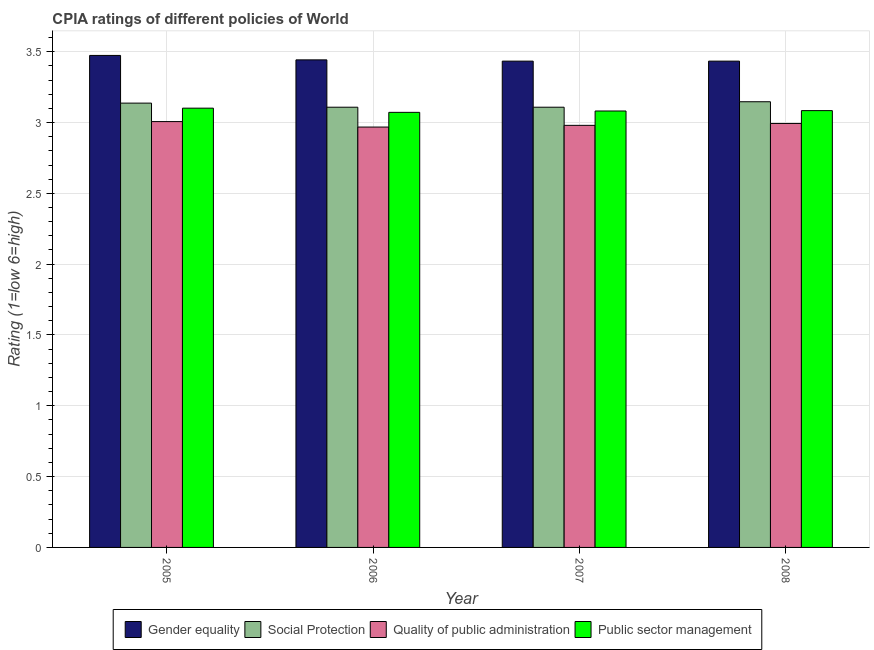How many different coloured bars are there?
Give a very brief answer. 4. How many groups of bars are there?
Make the answer very short. 4. Are the number of bars per tick equal to the number of legend labels?
Give a very brief answer. Yes. Are the number of bars on each tick of the X-axis equal?
Offer a very short reply. Yes. How many bars are there on the 3rd tick from the left?
Offer a terse response. 4. What is the label of the 3rd group of bars from the left?
Offer a very short reply. 2007. In how many cases, is the number of bars for a given year not equal to the number of legend labels?
Your answer should be compact. 0. What is the cpia rating of quality of public administration in 2007?
Keep it short and to the point. 2.98. Across all years, what is the maximum cpia rating of social protection?
Provide a short and direct response. 3.15. Across all years, what is the minimum cpia rating of gender equality?
Provide a short and direct response. 3.43. In which year was the cpia rating of quality of public administration maximum?
Make the answer very short. 2005. In which year was the cpia rating of quality of public administration minimum?
Offer a very short reply. 2006. What is the total cpia rating of quality of public administration in the graph?
Keep it short and to the point. 11.95. What is the difference between the cpia rating of quality of public administration in 2006 and that in 2007?
Ensure brevity in your answer.  -0.01. What is the difference between the cpia rating of gender equality in 2007 and the cpia rating of social protection in 2006?
Provide a succinct answer. -0.01. What is the average cpia rating of gender equality per year?
Keep it short and to the point. 3.45. In how many years, is the cpia rating of quality of public administration greater than 1.2?
Offer a terse response. 4. What is the ratio of the cpia rating of social protection in 2006 to that in 2008?
Offer a very short reply. 0.99. Is the cpia rating of quality of public administration in 2006 less than that in 2008?
Ensure brevity in your answer.  Yes. What is the difference between the highest and the second highest cpia rating of quality of public administration?
Offer a terse response. 0.01. What is the difference between the highest and the lowest cpia rating of quality of public administration?
Provide a short and direct response. 0.04. In how many years, is the cpia rating of quality of public administration greater than the average cpia rating of quality of public administration taken over all years?
Provide a short and direct response. 2. Is it the case that in every year, the sum of the cpia rating of gender equality and cpia rating of social protection is greater than the sum of cpia rating of public sector management and cpia rating of quality of public administration?
Offer a terse response. Yes. What does the 3rd bar from the left in 2005 represents?
Keep it short and to the point. Quality of public administration. What does the 3rd bar from the right in 2006 represents?
Keep it short and to the point. Social Protection. Is it the case that in every year, the sum of the cpia rating of gender equality and cpia rating of social protection is greater than the cpia rating of quality of public administration?
Offer a terse response. Yes. How many years are there in the graph?
Offer a terse response. 4. What is the difference between two consecutive major ticks on the Y-axis?
Provide a succinct answer. 0.5. Are the values on the major ticks of Y-axis written in scientific E-notation?
Your answer should be very brief. No. Where does the legend appear in the graph?
Provide a succinct answer. Bottom center. How are the legend labels stacked?
Offer a terse response. Horizontal. What is the title of the graph?
Offer a terse response. CPIA ratings of different policies of World. What is the label or title of the X-axis?
Keep it short and to the point. Year. What is the label or title of the Y-axis?
Provide a succinct answer. Rating (1=low 6=high). What is the Rating (1=low 6=high) in Gender equality in 2005?
Make the answer very short. 3.47. What is the Rating (1=low 6=high) in Social Protection in 2005?
Your answer should be compact. 3.14. What is the Rating (1=low 6=high) of Quality of public administration in 2005?
Your response must be concise. 3.01. What is the Rating (1=low 6=high) in Public sector management in 2005?
Offer a terse response. 3.1. What is the Rating (1=low 6=high) in Gender equality in 2006?
Make the answer very short. 3.44. What is the Rating (1=low 6=high) of Social Protection in 2006?
Keep it short and to the point. 3.11. What is the Rating (1=low 6=high) of Quality of public administration in 2006?
Provide a short and direct response. 2.97. What is the Rating (1=low 6=high) of Public sector management in 2006?
Offer a terse response. 3.07. What is the Rating (1=low 6=high) in Gender equality in 2007?
Your answer should be compact. 3.43. What is the Rating (1=low 6=high) of Social Protection in 2007?
Keep it short and to the point. 3.11. What is the Rating (1=low 6=high) of Quality of public administration in 2007?
Give a very brief answer. 2.98. What is the Rating (1=low 6=high) of Public sector management in 2007?
Keep it short and to the point. 3.08. What is the Rating (1=low 6=high) of Gender equality in 2008?
Your answer should be very brief. 3.43. What is the Rating (1=low 6=high) in Social Protection in 2008?
Give a very brief answer. 3.15. What is the Rating (1=low 6=high) of Quality of public administration in 2008?
Ensure brevity in your answer.  2.99. What is the Rating (1=low 6=high) in Public sector management in 2008?
Ensure brevity in your answer.  3.08. Across all years, what is the maximum Rating (1=low 6=high) of Gender equality?
Make the answer very short. 3.47. Across all years, what is the maximum Rating (1=low 6=high) of Social Protection?
Keep it short and to the point. 3.15. Across all years, what is the maximum Rating (1=low 6=high) in Quality of public administration?
Give a very brief answer. 3.01. Across all years, what is the maximum Rating (1=low 6=high) in Public sector management?
Your answer should be very brief. 3.1. Across all years, what is the minimum Rating (1=low 6=high) of Gender equality?
Your answer should be very brief. 3.43. Across all years, what is the minimum Rating (1=low 6=high) in Social Protection?
Make the answer very short. 3.11. Across all years, what is the minimum Rating (1=low 6=high) of Quality of public administration?
Offer a very short reply. 2.97. Across all years, what is the minimum Rating (1=low 6=high) in Public sector management?
Your answer should be very brief. 3.07. What is the total Rating (1=low 6=high) in Gender equality in the graph?
Give a very brief answer. 13.78. What is the total Rating (1=low 6=high) of Social Protection in the graph?
Your answer should be very brief. 12.5. What is the total Rating (1=low 6=high) of Quality of public administration in the graph?
Provide a succinct answer. 11.95. What is the total Rating (1=low 6=high) of Public sector management in the graph?
Your answer should be very brief. 12.34. What is the difference between the Rating (1=low 6=high) of Gender equality in 2005 and that in 2006?
Your response must be concise. 0.03. What is the difference between the Rating (1=low 6=high) of Social Protection in 2005 and that in 2006?
Offer a terse response. 0.03. What is the difference between the Rating (1=low 6=high) of Quality of public administration in 2005 and that in 2006?
Make the answer very short. 0.04. What is the difference between the Rating (1=low 6=high) in Public sector management in 2005 and that in 2006?
Give a very brief answer. 0.03. What is the difference between the Rating (1=low 6=high) of Gender equality in 2005 and that in 2007?
Your response must be concise. 0.04. What is the difference between the Rating (1=low 6=high) in Social Protection in 2005 and that in 2007?
Keep it short and to the point. 0.03. What is the difference between the Rating (1=low 6=high) in Quality of public administration in 2005 and that in 2007?
Offer a very short reply. 0.03. What is the difference between the Rating (1=low 6=high) of Gender equality in 2005 and that in 2008?
Your answer should be very brief. 0.04. What is the difference between the Rating (1=low 6=high) of Social Protection in 2005 and that in 2008?
Provide a succinct answer. -0.01. What is the difference between the Rating (1=low 6=high) in Quality of public administration in 2005 and that in 2008?
Provide a succinct answer. 0.01. What is the difference between the Rating (1=low 6=high) of Public sector management in 2005 and that in 2008?
Keep it short and to the point. 0.02. What is the difference between the Rating (1=low 6=high) in Gender equality in 2006 and that in 2007?
Give a very brief answer. 0.01. What is the difference between the Rating (1=low 6=high) in Quality of public administration in 2006 and that in 2007?
Provide a succinct answer. -0.01. What is the difference between the Rating (1=low 6=high) in Public sector management in 2006 and that in 2007?
Give a very brief answer. -0.01. What is the difference between the Rating (1=low 6=high) of Gender equality in 2006 and that in 2008?
Offer a very short reply. 0.01. What is the difference between the Rating (1=low 6=high) in Social Protection in 2006 and that in 2008?
Offer a very short reply. -0.04. What is the difference between the Rating (1=low 6=high) of Quality of public administration in 2006 and that in 2008?
Make the answer very short. -0.03. What is the difference between the Rating (1=low 6=high) of Public sector management in 2006 and that in 2008?
Offer a terse response. -0.01. What is the difference between the Rating (1=low 6=high) of Gender equality in 2007 and that in 2008?
Your response must be concise. 0. What is the difference between the Rating (1=low 6=high) of Social Protection in 2007 and that in 2008?
Offer a terse response. -0.04. What is the difference between the Rating (1=low 6=high) in Quality of public administration in 2007 and that in 2008?
Keep it short and to the point. -0.01. What is the difference between the Rating (1=low 6=high) in Public sector management in 2007 and that in 2008?
Give a very brief answer. -0. What is the difference between the Rating (1=low 6=high) of Gender equality in 2005 and the Rating (1=low 6=high) of Social Protection in 2006?
Your response must be concise. 0.37. What is the difference between the Rating (1=low 6=high) in Gender equality in 2005 and the Rating (1=low 6=high) in Quality of public administration in 2006?
Provide a short and direct response. 0.51. What is the difference between the Rating (1=low 6=high) in Gender equality in 2005 and the Rating (1=low 6=high) in Public sector management in 2006?
Keep it short and to the point. 0.4. What is the difference between the Rating (1=low 6=high) of Social Protection in 2005 and the Rating (1=low 6=high) of Quality of public administration in 2006?
Ensure brevity in your answer.  0.17. What is the difference between the Rating (1=low 6=high) in Social Protection in 2005 and the Rating (1=low 6=high) in Public sector management in 2006?
Offer a terse response. 0.07. What is the difference between the Rating (1=low 6=high) in Quality of public administration in 2005 and the Rating (1=low 6=high) in Public sector management in 2006?
Give a very brief answer. -0.07. What is the difference between the Rating (1=low 6=high) of Gender equality in 2005 and the Rating (1=low 6=high) of Social Protection in 2007?
Ensure brevity in your answer.  0.37. What is the difference between the Rating (1=low 6=high) of Gender equality in 2005 and the Rating (1=low 6=high) of Quality of public administration in 2007?
Keep it short and to the point. 0.49. What is the difference between the Rating (1=low 6=high) in Gender equality in 2005 and the Rating (1=low 6=high) in Public sector management in 2007?
Your response must be concise. 0.39. What is the difference between the Rating (1=low 6=high) of Social Protection in 2005 and the Rating (1=low 6=high) of Quality of public administration in 2007?
Offer a terse response. 0.16. What is the difference between the Rating (1=low 6=high) in Social Protection in 2005 and the Rating (1=low 6=high) in Public sector management in 2007?
Give a very brief answer. 0.06. What is the difference between the Rating (1=low 6=high) in Quality of public administration in 2005 and the Rating (1=low 6=high) in Public sector management in 2007?
Your answer should be very brief. -0.07. What is the difference between the Rating (1=low 6=high) of Gender equality in 2005 and the Rating (1=low 6=high) of Social Protection in 2008?
Your answer should be very brief. 0.33. What is the difference between the Rating (1=low 6=high) of Gender equality in 2005 and the Rating (1=low 6=high) of Quality of public administration in 2008?
Offer a very short reply. 0.48. What is the difference between the Rating (1=low 6=high) of Gender equality in 2005 and the Rating (1=low 6=high) of Public sector management in 2008?
Offer a terse response. 0.39. What is the difference between the Rating (1=low 6=high) in Social Protection in 2005 and the Rating (1=low 6=high) in Quality of public administration in 2008?
Offer a very short reply. 0.14. What is the difference between the Rating (1=low 6=high) in Social Protection in 2005 and the Rating (1=low 6=high) in Public sector management in 2008?
Offer a very short reply. 0.05. What is the difference between the Rating (1=low 6=high) in Quality of public administration in 2005 and the Rating (1=low 6=high) in Public sector management in 2008?
Ensure brevity in your answer.  -0.08. What is the difference between the Rating (1=low 6=high) in Gender equality in 2006 and the Rating (1=low 6=high) in Social Protection in 2007?
Make the answer very short. 0.33. What is the difference between the Rating (1=low 6=high) in Gender equality in 2006 and the Rating (1=low 6=high) in Quality of public administration in 2007?
Offer a very short reply. 0.46. What is the difference between the Rating (1=low 6=high) in Gender equality in 2006 and the Rating (1=low 6=high) in Public sector management in 2007?
Provide a short and direct response. 0.36. What is the difference between the Rating (1=low 6=high) of Social Protection in 2006 and the Rating (1=low 6=high) of Quality of public administration in 2007?
Ensure brevity in your answer.  0.13. What is the difference between the Rating (1=low 6=high) of Social Protection in 2006 and the Rating (1=low 6=high) of Public sector management in 2007?
Your answer should be very brief. 0.03. What is the difference between the Rating (1=low 6=high) of Quality of public administration in 2006 and the Rating (1=low 6=high) of Public sector management in 2007?
Provide a short and direct response. -0.11. What is the difference between the Rating (1=low 6=high) of Gender equality in 2006 and the Rating (1=low 6=high) of Social Protection in 2008?
Offer a very short reply. 0.3. What is the difference between the Rating (1=low 6=high) of Gender equality in 2006 and the Rating (1=low 6=high) of Quality of public administration in 2008?
Make the answer very short. 0.45. What is the difference between the Rating (1=low 6=high) of Gender equality in 2006 and the Rating (1=low 6=high) of Public sector management in 2008?
Offer a very short reply. 0.36. What is the difference between the Rating (1=low 6=high) of Social Protection in 2006 and the Rating (1=low 6=high) of Quality of public administration in 2008?
Ensure brevity in your answer.  0.11. What is the difference between the Rating (1=low 6=high) in Social Protection in 2006 and the Rating (1=low 6=high) in Public sector management in 2008?
Provide a short and direct response. 0.02. What is the difference between the Rating (1=low 6=high) in Quality of public administration in 2006 and the Rating (1=low 6=high) in Public sector management in 2008?
Keep it short and to the point. -0.12. What is the difference between the Rating (1=low 6=high) in Gender equality in 2007 and the Rating (1=low 6=high) in Social Protection in 2008?
Ensure brevity in your answer.  0.29. What is the difference between the Rating (1=low 6=high) of Gender equality in 2007 and the Rating (1=low 6=high) of Quality of public administration in 2008?
Your response must be concise. 0.44. What is the difference between the Rating (1=low 6=high) in Gender equality in 2007 and the Rating (1=low 6=high) in Public sector management in 2008?
Your answer should be compact. 0.35. What is the difference between the Rating (1=low 6=high) in Social Protection in 2007 and the Rating (1=low 6=high) in Quality of public administration in 2008?
Provide a succinct answer. 0.11. What is the difference between the Rating (1=low 6=high) of Social Protection in 2007 and the Rating (1=low 6=high) of Public sector management in 2008?
Offer a terse response. 0.02. What is the difference between the Rating (1=low 6=high) in Quality of public administration in 2007 and the Rating (1=low 6=high) in Public sector management in 2008?
Your response must be concise. -0.1. What is the average Rating (1=low 6=high) in Gender equality per year?
Give a very brief answer. 3.45. What is the average Rating (1=low 6=high) of Social Protection per year?
Ensure brevity in your answer.  3.12. What is the average Rating (1=low 6=high) of Quality of public administration per year?
Keep it short and to the point. 2.99. What is the average Rating (1=low 6=high) of Public sector management per year?
Ensure brevity in your answer.  3.08. In the year 2005, what is the difference between the Rating (1=low 6=high) of Gender equality and Rating (1=low 6=high) of Social Protection?
Offer a very short reply. 0.34. In the year 2005, what is the difference between the Rating (1=low 6=high) in Gender equality and Rating (1=low 6=high) in Quality of public administration?
Keep it short and to the point. 0.47. In the year 2005, what is the difference between the Rating (1=low 6=high) in Gender equality and Rating (1=low 6=high) in Public sector management?
Provide a short and direct response. 0.37. In the year 2005, what is the difference between the Rating (1=low 6=high) of Social Protection and Rating (1=low 6=high) of Quality of public administration?
Give a very brief answer. 0.13. In the year 2005, what is the difference between the Rating (1=low 6=high) in Social Protection and Rating (1=low 6=high) in Public sector management?
Ensure brevity in your answer.  0.04. In the year 2005, what is the difference between the Rating (1=low 6=high) in Quality of public administration and Rating (1=low 6=high) in Public sector management?
Make the answer very short. -0.09. In the year 2006, what is the difference between the Rating (1=low 6=high) in Gender equality and Rating (1=low 6=high) in Social Protection?
Your answer should be very brief. 0.33. In the year 2006, what is the difference between the Rating (1=low 6=high) in Gender equality and Rating (1=low 6=high) in Quality of public administration?
Keep it short and to the point. 0.47. In the year 2006, what is the difference between the Rating (1=low 6=high) of Gender equality and Rating (1=low 6=high) of Public sector management?
Provide a short and direct response. 0.37. In the year 2006, what is the difference between the Rating (1=low 6=high) in Social Protection and Rating (1=low 6=high) in Quality of public administration?
Keep it short and to the point. 0.14. In the year 2006, what is the difference between the Rating (1=low 6=high) in Social Protection and Rating (1=low 6=high) in Public sector management?
Provide a succinct answer. 0.04. In the year 2006, what is the difference between the Rating (1=low 6=high) in Quality of public administration and Rating (1=low 6=high) in Public sector management?
Ensure brevity in your answer.  -0.1. In the year 2007, what is the difference between the Rating (1=low 6=high) of Gender equality and Rating (1=low 6=high) of Social Protection?
Make the answer very short. 0.33. In the year 2007, what is the difference between the Rating (1=low 6=high) in Gender equality and Rating (1=low 6=high) in Quality of public administration?
Make the answer very short. 0.45. In the year 2007, what is the difference between the Rating (1=low 6=high) of Gender equality and Rating (1=low 6=high) of Public sector management?
Provide a succinct answer. 0.35. In the year 2007, what is the difference between the Rating (1=low 6=high) of Social Protection and Rating (1=low 6=high) of Quality of public administration?
Offer a terse response. 0.13. In the year 2007, what is the difference between the Rating (1=low 6=high) of Social Protection and Rating (1=low 6=high) of Public sector management?
Offer a very short reply. 0.03. In the year 2007, what is the difference between the Rating (1=low 6=high) of Quality of public administration and Rating (1=low 6=high) of Public sector management?
Offer a very short reply. -0.1. In the year 2008, what is the difference between the Rating (1=low 6=high) in Gender equality and Rating (1=low 6=high) in Social Protection?
Your answer should be very brief. 0.29. In the year 2008, what is the difference between the Rating (1=low 6=high) of Gender equality and Rating (1=low 6=high) of Quality of public administration?
Provide a short and direct response. 0.44. In the year 2008, what is the difference between the Rating (1=low 6=high) in Gender equality and Rating (1=low 6=high) in Public sector management?
Offer a very short reply. 0.35. In the year 2008, what is the difference between the Rating (1=low 6=high) in Social Protection and Rating (1=low 6=high) in Quality of public administration?
Provide a succinct answer. 0.15. In the year 2008, what is the difference between the Rating (1=low 6=high) in Social Protection and Rating (1=low 6=high) in Public sector management?
Offer a terse response. 0.06. In the year 2008, what is the difference between the Rating (1=low 6=high) in Quality of public administration and Rating (1=low 6=high) in Public sector management?
Ensure brevity in your answer.  -0.09. What is the ratio of the Rating (1=low 6=high) of Gender equality in 2005 to that in 2006?
Your response must be concise. 1.01. What is the ratio of the Rating (1=low 6=high) of Social Protection in 2005 to that in 2006?
Offer a terse response. 1.01. What is the ratio of the Rating (1=low 6=high) in Public sector management in 2005 to that in 2006?
Ensure brevity in your answer.  1.01. What is the ratio of the Rating (1=low 6=high) of Gender equality in 2005 to that in 2007?
Give a very brief answer. 1.01. What is the ratio of the Rating (1=low 6=high) of Social Protection in 2005 to that in 2007?
Give a very brief answer. 1.01. What is the ratio of the Rating (1=low 6=high) of Quality of public administration in 2005 to that in 2007?
Keep it short and to the point. 1.01. What is the ratio of the Rating (1=low 6=high) in Public sector management in 2005 to that in 2007?
Provide a succinct answer. 1.01. What is the ratio of the Rating (1=low 6=high) in Gender equality in 2005 to that in 2008?
Make the answer very short. 1.01. What is the ratio of the Rating (1=low 6=high) of Quality of public administration in 2005 to that in 2008?
Your response must be concise. 1. What is the ratio of the Rating (1=low 6=high) of Public sector management in 2005 to that in 2008?
Offer a very short reply. 1.01. What is the ratio of the Rating (1=low 6=high) of Gender equality in 2006 to that in 2007?
Your response must be concise. 1. What is the ratio of the Rating (1=low 6=high) of Quality of public administration in 2006 to that in 2007?
Ensure brevity in your answer.  1. What is the ratio of the Rating (1=low 6=high) of Gender equality in 2006 to that in 2008?
Keep it short and to the point. 1. What is the ratio of the Rating (1=low 6=high) of Social Protection in 2006 to that in 2008?
Offer a terse response. 0.99. What is the ratio of the Rating (1=low 6=high) of Gender equality in 2007 to that in 2008?
Keep it short and to the point. 1. What is the ratio of the Rating (1=low 6=high) in Social Protection in 2007 to that in 2008?
Offer a terse response. 0.99. What is the ratio of the Rating (1=low 6=high) in Public sector management in 2007 to that in 2008?
Provide a short and direct response. 1. What is the difference between the highest and the second highest Rating (1=low 6=high) in Gender equality?
Make the answer very short. 0.03. What is the difference between the highest and the second highest Rating (1=low 6=high) in Social Protection?
Ensure brevity in your answer.  0.01. What is the difference between the highest and the second highest Rating (1=low 6=high) of Quality of public administration?
Offer a very short reply. 0.01. What is the difference between the highest and the second highest Rating (1=low 6=high) in Public sector management?
Your answer should be very brief. 0.02. What is the difference between the highest and the lowest Rating (1=low 6=high) of Gender equality?
Your answer should be compact. 0.04. What is the difference between the highest and the lowest Rating (1=low 6=high) of Social Protection?
Your response must be concise. 0.04. What is the difference between the highest and the lowest Rating (1=low 6=high) in Quality of public administration?
Give a very brief answer. 0.04. What is the difference between the highest and the lowest Rating (1=low 6=high) of Public sector management?
Give a very brief answer. 0.03. 